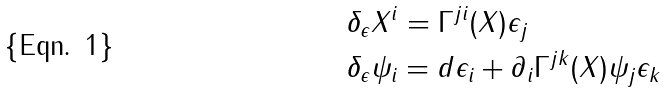Convert formula to latex. <formula><loc_0><loc_0><loc_500><loc_500>& \delta _ { \epsilon } X ^ { i } = \Gamma ^ { j i } ( X ) \epsilon _ { j } \\ & \delta _ { \epsilon } \psi _ { i } = d \epsilon _ { i } + \partial _ { i } \Gamma ^ { j k } ( X ) \psi _ { j } \epsilon _ { k }</formula> 